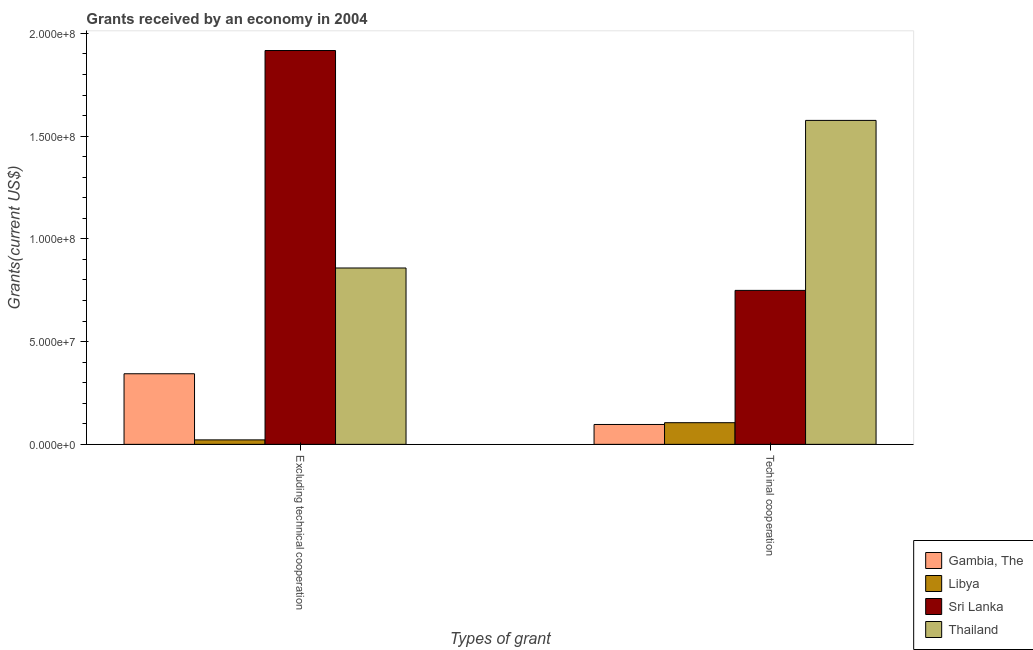Are the number of bars per tick equal to the number of legend labels?
Provide a succinct answer. Yes. How many bars are there on the 1st tick from the left?
Offer a terse response. 4. How many bars are there on the 1st tick from the right?
Offer a very short reply. 4. What is the label of the 1st group of bars from the left?
Offer a very short reply. Excluding technical cooperation. What is the amount of grants received(including technical cooperation) in Sri Lanka?
Offer a very short reply. 7.49e+07. Across all countries, what is the maximum amount of grants received(including technical cooperation)?
Make the answer very short. 1.58e+08. Across all countries, what is the minimum amount of grants received(including technical cooperation)?
Ensure brevity in your answer.  9.68e+06. In which country was the amount of grants received(excluding technical cooperation) maximum?
Offer a terse response. Sri Lanka. In which country was the amount of grants received(excluding technical cooperation) minimum?
Offer a terse response. Libya. What is the total amount of grants received(excluding technical cooperation) in the graph?
Provide a succinct answer. 3.14e+08. What is the difference between the amount of grants received(excluding technical cooperation) in Libya and that in Thailand?
Your answer should be very brief. -8.37e+07. What is the difference between the amount of grants received(excluding technical cooperation) in Gambia, The and the amount of grants received(including technical cooperation) in Libya?
Ensure brevity in your answer.  2.38e+07. What is the average amount of grants received(including technical cooperation) per country?
Provide a short and direct response. 6.32e+07. What is the difference between the amount of grants received(excluding technical cooperation) and amount of grants received(including technical cooperation) in Libya?
Offer a very short reply. -8.36e+06. In how many countries, is the amount of grants received(excluding technical cooperation) greater than 80000000 US$?
Your response must be concise. 2. What is the ratio of the amount of grants received(including technical cooperation) in Libya to that in Gambia, The?
Provide a short and direct response. 1.09. Is the amount of grants received(including technical cooperation) in Thailand less than that in Sri Lanka?
Provide a short and direct response. No. What does the 4th bar from the left in Techinal cooperation represents?
Keep it short and to the point. Thailand. What does the 2nd bar from the right in Excluding technical cooperation represents?
Your answer should be compact. Sri Lanka. How many bars are there?
Ensure brevity in your answer.  8. How many countries are there in the graph?
Your answer should be very brief. 4. What is the difference between two consecutive major ticks on the Y-axis?
Your response must be concise. 5.00e+07. Are the values on the major ticks of Y-axis written in scientific E-notation?
Make the answer very short. Yes. Where does the legend appear in the graph?
Offer a terse response. Bottom right. How are the legend labels stacked?
Provide a short and direct response. Vertical. What is the title of the graph?
Make the answer very short. Grants received by an economy in 2004. What is the label or title of the X-axis?
Make the answer very short. Types of grant. What is the label or title of the Y-axis?
Offer a very short reply. Grants(current US$). What is the Grants(current US$) in Gambia, The in Excluding technical cooperation?
Offer a terse response. 3.44e+07. What is the Grants(current US$) in Libya in Excluding technical cooperation?
Offer a very short reply. 2.18e+06. What is the Grants(current US$) in Sri Lanka in Excluding technical cooperation?
Your response must be concise. 1.92e+08. What is the Grants(current US$) in Thailand in Excluding technical cooperation?
Your answer should be very brief. 8.58e+07. What is the Grants(current US$) in Gambia, The in Techinal cooperation?
Give a very brief answer. 9.68e+06. What is the Grants(current US$) of Libya in Techinal cooperation?
Offer a very short reply. 1.05e+07. What is the Grants(current US$) of Sri Lanka in Techinal cooperation?
Your response must be concise. 7.49e+07. What is the Grants(current US$) of Thailand in Techinal cooperation?
Ensure brevity in your answer.  1.58e+08. Across all Types of grant, what is the maximum Grants(current US$) of Gambia, The?
Your answer should be compact. 3.44e+07. Across all Types of grant, what is the maximum Grants(current US$) in Libya?
Give a very brief answer. 1.05e+07. Across all Types of grant, what is the maximum Grants(current US$) in Sri Lanka?
Offer a terse response. 1.92e+08. Across all Types of grant, what is the maximum Grants(current US$) of Thailand?
Your answer should be very brief. 1.58e+08. Across all Types of grant, what is the minimum Grants(current US$) of Gambia, The?
Provide a short and direct response. 9.68e+06. Across all Types of grant, what is the minimum Grants(current US$) in Libya?
Make the answer very short. 2.18e+06. Across all Types of grant, what is the minimum Grants(current US$) of Sri Lanka?
Give a very brief answer. 7.49e+07. Across all Types of grant, what is the minimum Grants(current US$) of Thailand?
Make the answer very short. 8.58e+07. What is the total Grants(current US$) in Gambia, The in the graph?
Ensure brevity in your answer.  4.40e+07. What is the total Grants(current US$) in Libya in the graph?
Give a very brief answer. 1.27e+07. What is the total Grants(current US$) in Sri Lanka in the graph?
Offer a very short reply. 2.67e+08. What is the total Grants(current US$) in Thailand in the graph?
Offer a terse response. 2.44e+08. What is the difference between the Grants(current US$) of Gambia, The in Excluding technical cooperation and that in Techinal cooperation?
Your answer should be very brief. 2.47e+07. What is the difference between the Grants(current US$) in Libya in Excluding technical cooperation and that in Techinal cooperation?
Ensure brevity in your answer.  -8.36e+06. What is the difference between the Grants(current US$) of Sri Lanka in Excluding technical cooperation and that in Techinal cooperation?
Provide a short and direct response. 1.17e+08. What is the difference between the Grants(current US$) of Thailand in Excluding technical cooperation and that in Techinal cooperation?
Offer a terse response. -7.18e+07. What is the difference between the Grants(current US$) in Gambia, The in Excluding technical cooperation and the Grants(current US$) in Libya in Techinal cooperation?
Your answer should be compact. 2.38e+07. What is the difference between the Grants(current US$) in Gambia, The in Excluding technical cooperation and the Grants(current US$) in Sri Lanka in Techinal cooperation?
Provide a succinct answer. -4.06e+07. What is the difference between the Grants(current US$) of Gambia, The in Excluding technical cooperation and the Grants(current US$) of Thailand in Techinal cooperation?
Provide a succinct answer. -1.23e+08. What is the difference between the Grants(current US$) of Libya in Excluding technical cooperation and the Grants(current US$) of Sri Lanka in Techinal cooperation?
Offer a very short reply. -7.28e+07. What is the difference between the Grants(current US$) of Libya in Excluding technical cooperation and the Grants(current US$) of Thailand in Techinal cooperation?
Give a very brief answer. -1.56e+08. What is the difference between the Grants(current US$) of Sri Lanka in Excluding technical cooperation and the Grants(current US$) of Thailand in Techinal cooperation?
Offer a terse response. 3.40e+07. What is the average Grants(current US$) in Gambia, The per Types of grant?
Provide a short and direct response. 2.20e+07. What is the average Grants(current US$) of Libya per Types of grant?
Your answer should be compact. 6.36e+06. What is the average Grants(current US$) in Sri Lanka per Types of grant?
Your response must be concise. 1.33e+08. What is the average Grants(current US$) of Thailand per Types of grant?
Provide a short and direct response. 1.22e+08. What is the difference between the Grants(current US$) in Gambia, The and Grants(current US$) in Libya in Excluding technical cooperation?
Ensure brevity in your answer.  3.22e+07. What is the difference between the Grants(current US$) in Gambia, The and Grants(current US$) in Sri Lanka in Excluding technical cooperation?
Keep it short and to the point. -1.57e+08. What is the difference between the Grants(current US$) of Gambia, The and Grants(current US$) of Thailand in Excluding technical cooperation?
Make the answer very short. -5.15e+07. What is the difference between the Grants(current US$) of Libya and Grants(current US$) of Sri Lanka in Excluding technical cooperation?
Make the answer very short. -1.90e+08. What is the difference between the Grants(current US$) of Libya and Grants(current US$) of Thailand in Excluding technical cooperation?
Your response must be concise. -8.37e+07. What is the difference between the Grants(current US$) in Sri Lanka and Grants(current US$) in Thailand in Excluding technical cooperation?
Your answer should be compact. 1.06e+08. What is the difference between the Grants(current US$) in Gambia, The and Grants(current US$) in Libya in Techinal cooperation?
Ensure brevity in your answer.  -8.60e+05. What is the difference between the Grants(current US$) in Gambia, The and Grants(current US$) in Sri Lanka in Techinal cooperation?
Provide a succinct answer. -6.53e+07. What is the difference between the Grants(current US$) in Gambia, The and Grants(current US$) in Thailand in Techinal cooperation?
Offer a very short reply. -1.48e+08. What is the difference between the Grants(current US$) in Libya and Grants(current US$) in Sri Lanka in Techinal cooperation?
Provide a succinct answer. -6.44e+07. What is the difference between the Grants(current US$) in Libya and Grants(current US$) in Thailand in Techinal cooperation?
Make the answer very short. -1.47e+08. What is the difference between the Grants(current US$) in Sri Lanka and Grants(current US$) in Thailand in Techinal cooperation?
Your answer should be compact. -8.27e+07. What is the ratio of the Grants(current US$) of Gambia, The in Excluding technical cooperation to that in Techinal cooperation?
Give a very brief answer. 3.55. What is the ratio of the Grants(current US$) in Libya in Excluding technical cooperation to that in Techinal cooperation?
Offer a very short reply. 0.21. What is the ratio of the Grants(current US$) of Sri Lanka in Excluding technical cooperation to that in Techinal cooperation?
Keep it short and to the point. 2.56. What is the ratio of the Grants(current US$) in Thailand in Excluding technical cooperation to that in Techinal cooperation?
Provide a succinct answer. 0.54. What is the difference between the highest and the second highest Grants(current US$) in Gambia, The?
Ensure brevity in your answer.  2.47e+07. What is the difference between the highest and the second highest Grants(current US$) in Libya?
Your response must be concise. 8.36e+06. What is the difference between the highest and the second highest Grants(current US$) in Sri Lanka?
Your answer should be very brief. 1.17e+08. What is the difference between the highest and the second highest Grants(current US$) in Thailand?
Your response must be concise. 7.18e+07. What is the difference between the highest and the lowest Grants(current US$) in Gambia, The?
Provide a short and direct response. 2.47e+07. What is the difference between the highest and the lowest Grants(current US$) in Libya?
Ensure brevity in your answer.  8.36e+06. What is the difference between the highest and the lowest Grants(current US$) of Sri Lanka?
Keep it short and to the point. 1.17e+08. What is the difference between the highest and the lowest Grants(current US$) of Thailand?
Your response must be concise. 7.18e+07. 